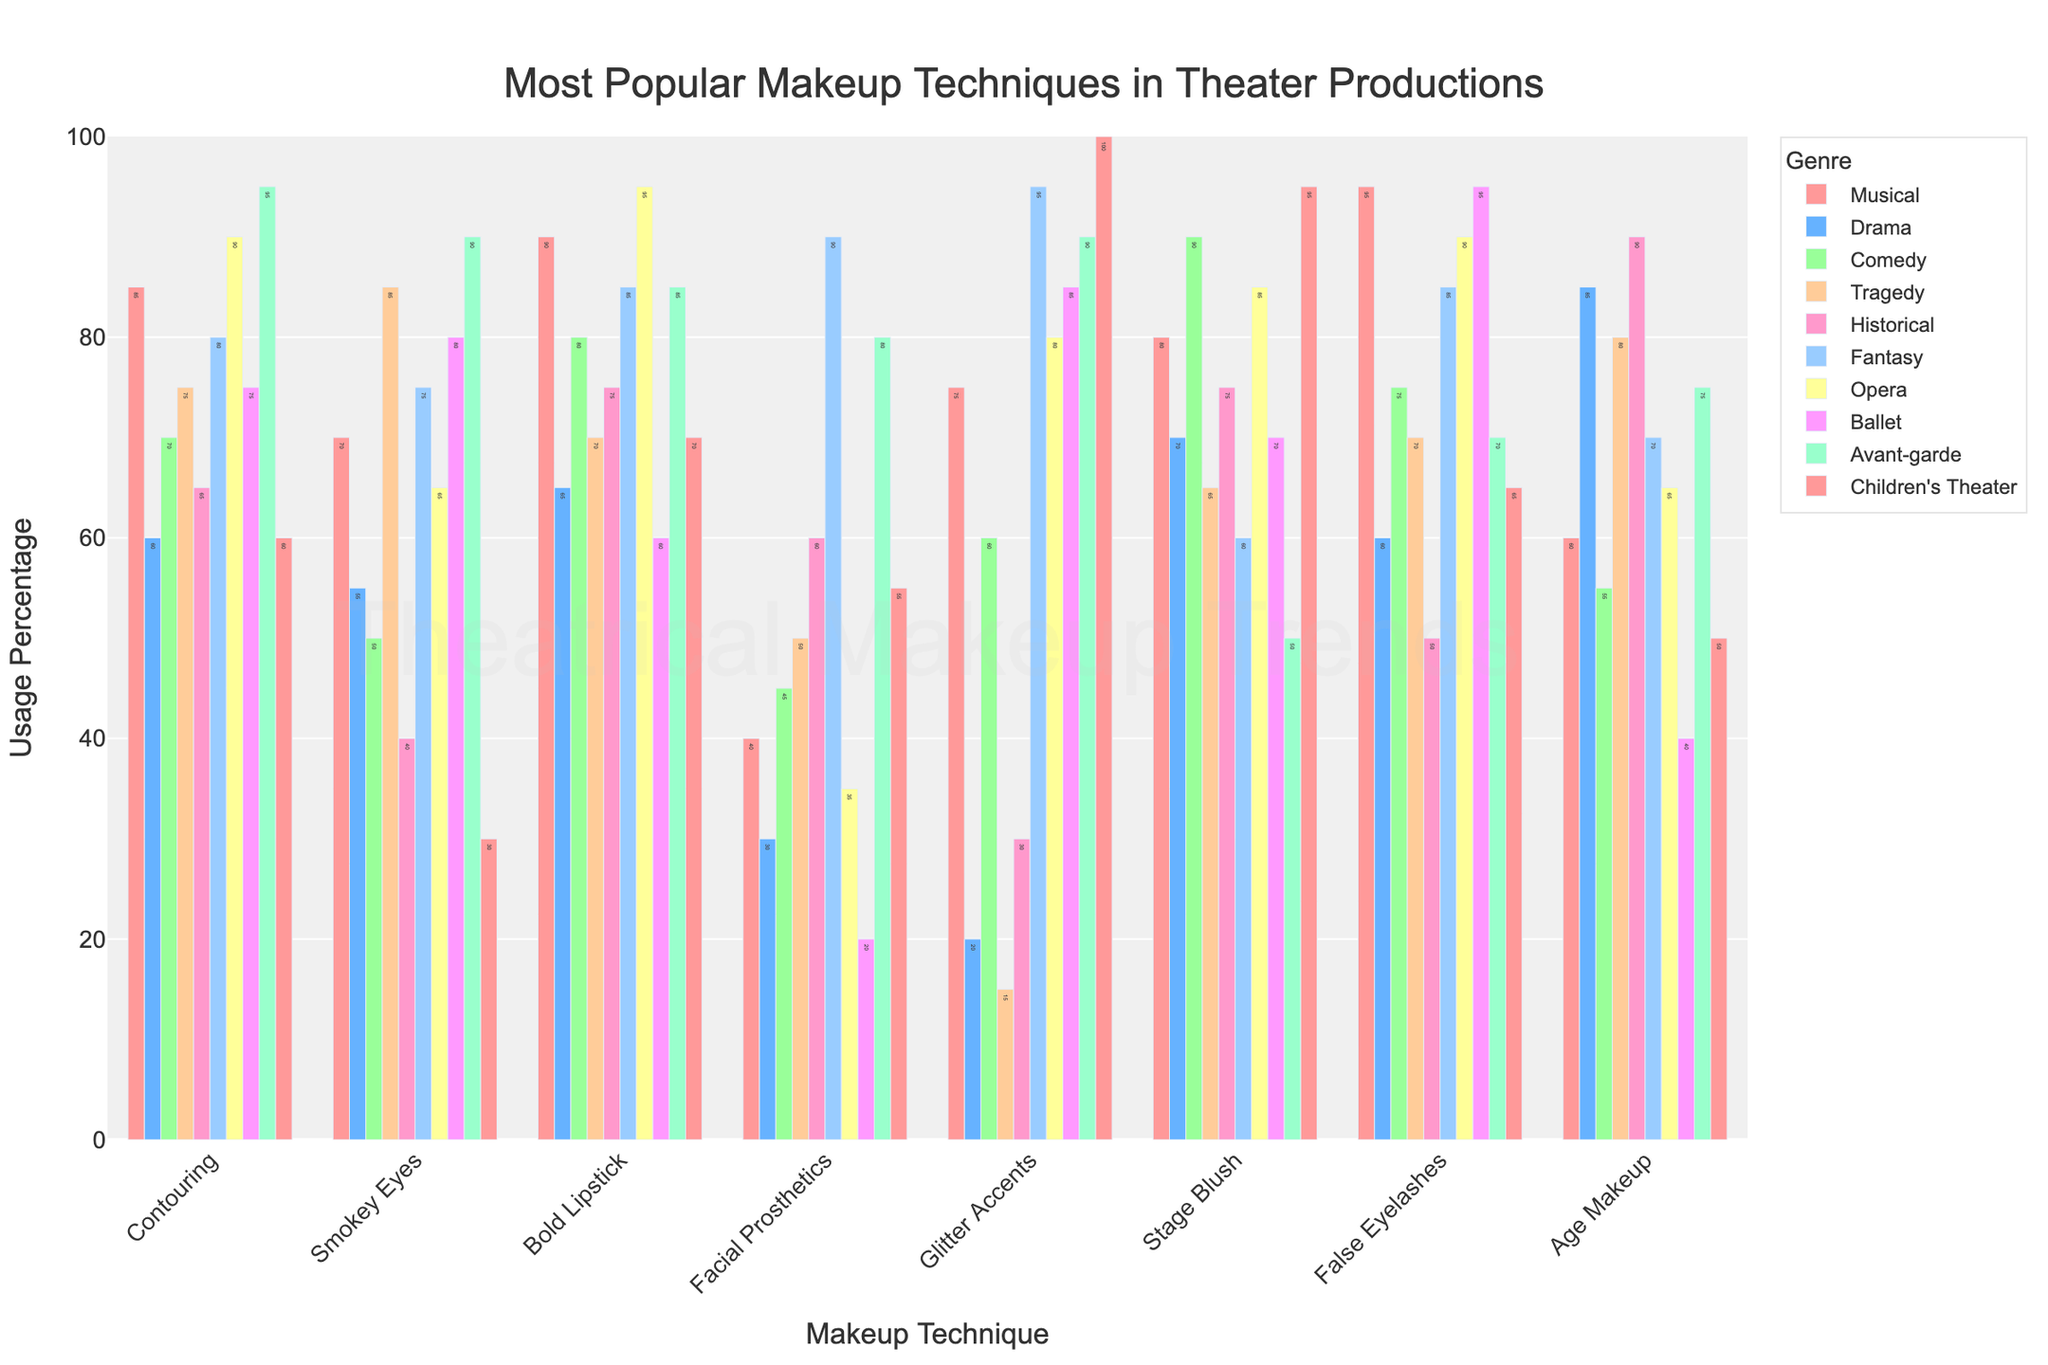Which genre uses Facial Prosthetics the most? Look at the height of the bars for Facial Prosthetics across all genres; the tallest bar indicates the genre that uses it the most. Fantasy has the highest bar for Facial Prosthetics.
Answer: Fantasy Is Bold Lipstick used more in Musicals or Dramas? Compare the height of the bars for Bold Lipstick in both Musicals and Dramas. The bar for Musicals is higher than that for Dramas.
Answer: Musicals How does the usage of Glitter Accents in Fantasy compare to Children's Theater? Observe the bars for Glitter Accents in both Fantasy and Children's Theater; both are equally high. This means the usage is the same in both genres.
Answer: Equal What's the most popular makeup technique in Ballet? Identify the tallest bar among all makeup techniques for Ballet. The False Eyelashes bar is the highest.
Answer: False Eyelashes In which genre is Age Makeup more commonly used, Drama or Comedy? Compare the heights of the Age Makeup bars in Drama and Comedy. The bar is higher for Drama.
Answer: Drama Which genre has the lowest usage of Smokey Eyes? Find the shortest bar under Smokey Eyes across all genres. Children's Theater has the shortest bar for Smokey Eyes.
Answer: Children's Theater Calculate the average usage of Contouring across all genres. Add the usage percentages for Contouring in all genres and divide by the number of genres. (85+60+70+75+65+80+90+75+95+60) / 10 = 75.5
Answer: 75.5 How much more popular is Stage Blush in Comedy compared to Fantasy? Subtract the usage percentage of Stage Blush in Fantasy from that in Comedy. (90 - 60) = 30
Answer: 30 Which makeup technique is most popular overall? By comparing the tallest bars across all techniques, the False Eyelashes bar is consistently high across multiple genres, indicating it as the most popular.
Answer: False Eyelashes What's the difference in Age Makeup usage in Historical and Ballet genres? Subtract the Age Makeup percentage in Ballet from that in Historical. (90 - 40) = 50
Answer: 50 